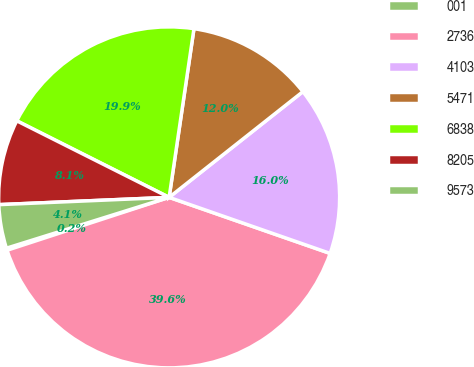Convert chart to OTSL. <chart><loc_0><loc_0><loc_500><loc_500><pie_chart><fcel>001<fcel>2736<fcel>4103<fcel>5471<fcel>6838<fcel>8205<fcel>9573<nl><fcel>0.2%<fcel>39.65%<fcel>15.98%<fcel>12.03%<fcel>19.92%<fcel>8.09%<fcel>4.14%<nl></chart> 